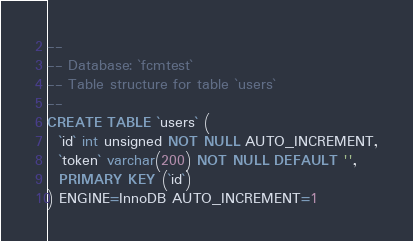Convert code to text. <code><loc_0><loc_0><loc_500><loc_500><_SQL_>--
-- Database: `fcmtest`
-- Table structure for table `users`
--
CREATE TABLE `users` (
  `id` int unsigned NOT NULL AUTO_INCREMENT,
  `token` varchar(200) NOT NULL DEFAULT '',
  PRIMARY KEY (`id`)
) ENGINE=InnoDB AUTO_INCREMENT=1</code> 